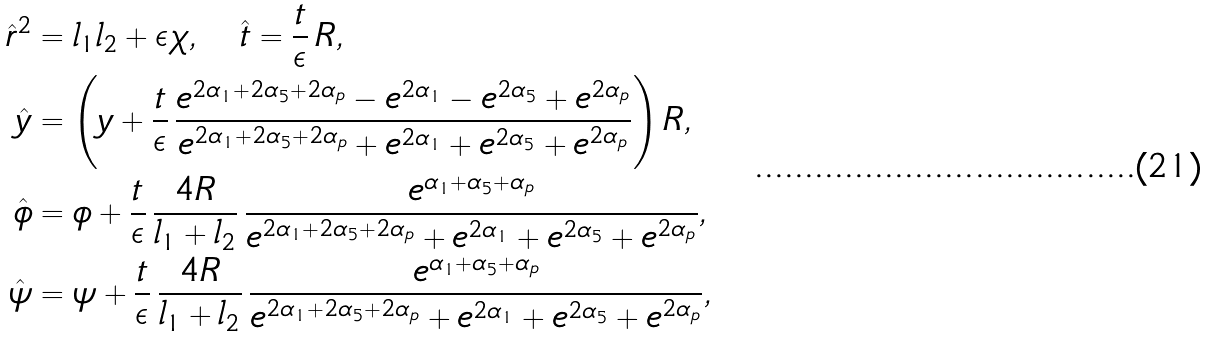<formula> <loc_0><loc_0><loc_500><loc_500>\hat { r } ^ { 2 } & = l _ { 1 } l _ { 2 } + \epsilon \chi , \quad \hat { t } = \frac { t } { \epsilon } \, R , \\ \hat { y } & = \left ( y + \frac { t } { \epsilon } \, \frac { e ^ { 2 \alpha _ { 1 } + 2 \alpha _ { 5 } + 2 \alpha _ { p } } - e ^ { 2 \alpha _ { 1 } } - e ^ { 2 \alpha _ { 5 } } + e ^ { 2 \alpha _ { p } } } { e ^ { 2 \alpha _ { 1 } + 2 \alpha _ { 5 } + 2 \alpha _ { p } } + e ^ { 2 \alpha _ { 1 } } + e ^ { 2 \alpha _ { 5 } } + e ^ { 2 \alpha _ { p } } } \right ) R , \\ \hat { \phi } & = \phi + \frac { t } { \epsilon } \, \frac { 4 R } { l _ { 1 } + l _ { 2 } } \, \frac { e ^ { \alpha _ { 1 } + \alpha _ { 5 } + \alpha _ { p } } } { e ^ { 2 \alpha _ { 1 } + 2 \alpha _ { 5 } + 2 \alpha _ { p } } + e ^ { 2 \alpha _ { 1 } } + e ^ { 2 \alpha _ { 5 } } + e ^ { 2 \alpha _ { p } } } , \\ \hat { \psi } & = \psi + \frac { t } { \epsilon } \, \frac { 4 R } { l _ { 1 } + l _ { 2 } } \, \frac { e ^ { \alpha _ { 1 } + \alpha _ { 5 } + \alpha _ { p } } } { e ^ { 2 \alpha _ { 1 } + 2 \alpha _ { 5 } + 2 \alpha _ { p } } + e ^ { 2 \alpha _ { 1 } } + e ^ { 2 \alpha _ { 5 } } + e ^ { 2 \alpha _ { p } } } ,</formula> 